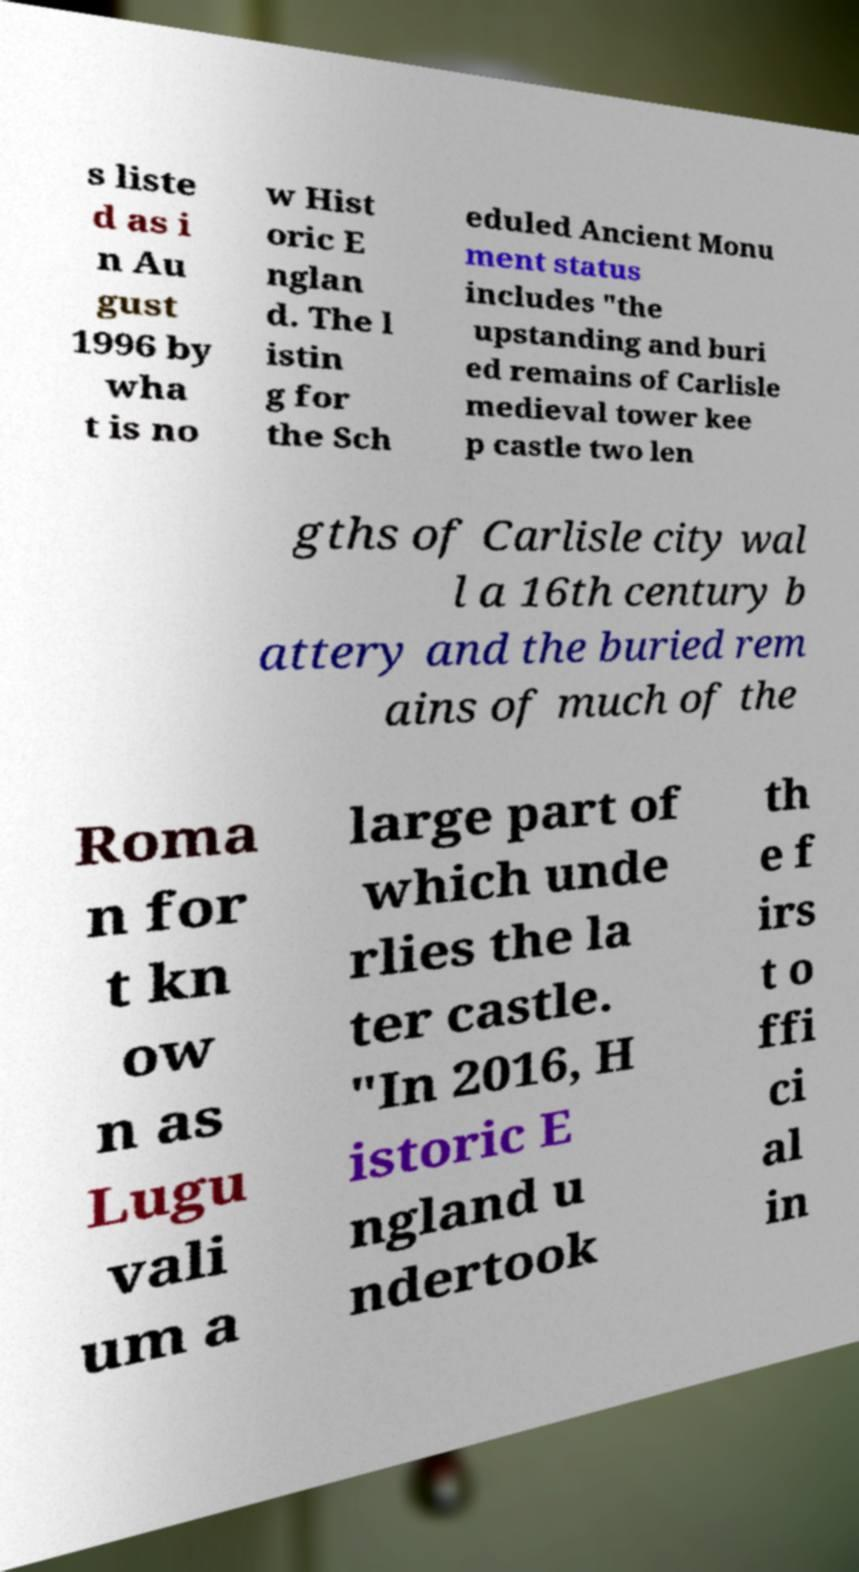Could you assist in decoding the text presented in this image and type it out clearly? s liste d as i n Au gust 1996 by wha t is no w Hist oric E nglan d. The l istin g for the Sch eduled Ancient Monu ment status includes "the upstanding and buri ed remains of Carlisle medieval tower kee p castle two len gths of Carlisle city wal l a 16th century b attery and the buried rem ains of much of the Roma n for t kn ow n as Lugu vali um a large part of which unde rlies the la ter castle. "In 2016, H istoric E ngland u ndertook th e f irs t o ffi ci al in 